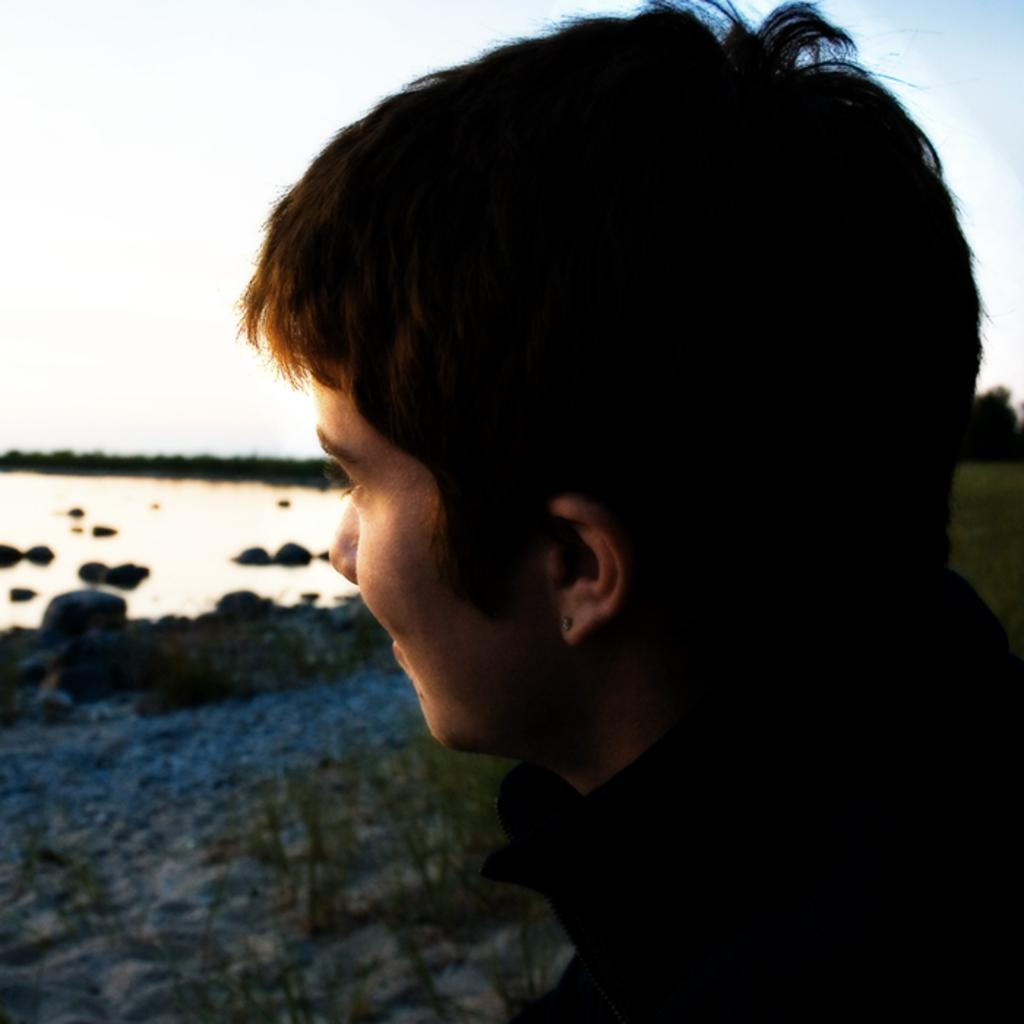Who or what is present in the image? There is a person in the image. What is the primary element visible in the image? Water is visible in the image. What other natural features can be seen in the image? There are rocks and trees in the image. What can be seen in the background of the image? The sky is visible in the background of the image. What type of juice is being served to the children in the image? There are no children or juice present in the image. 